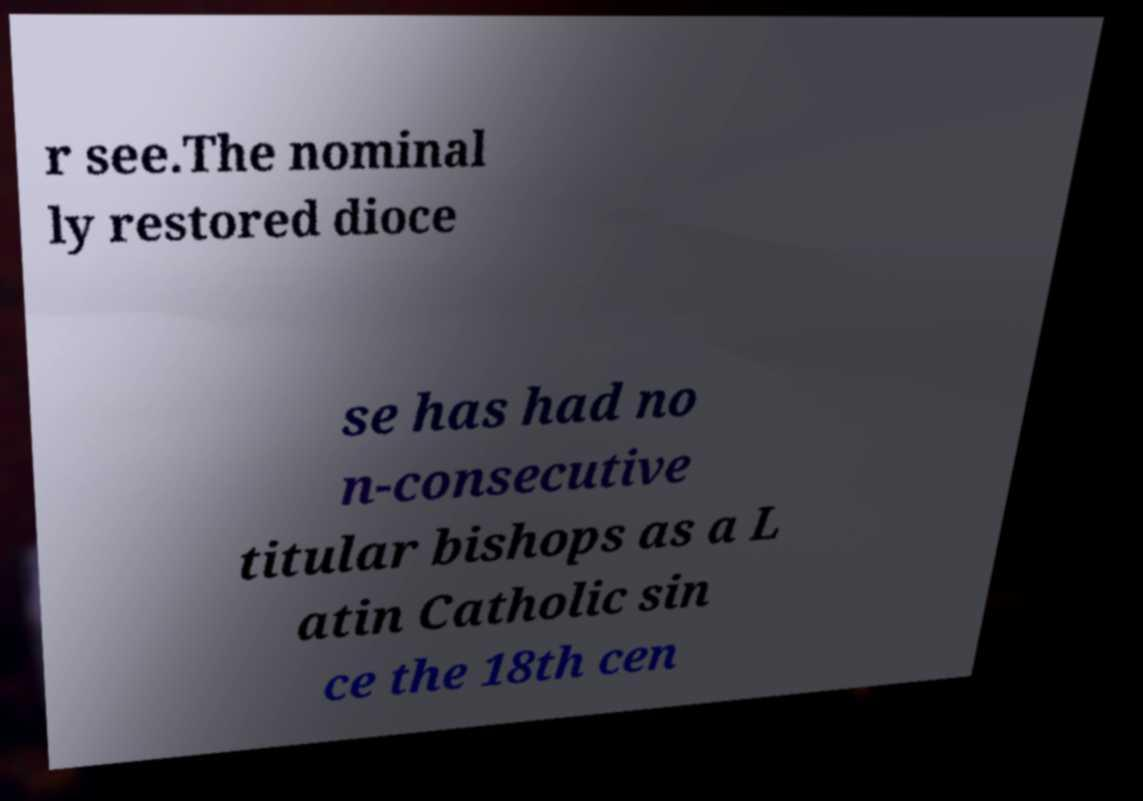I need the written content from this picture converted into text. Can you do that? r see.The nominal ly restored dioce se has had no n-consecutive titular bishops as a L atin Catholic sin ce the 18th cen 